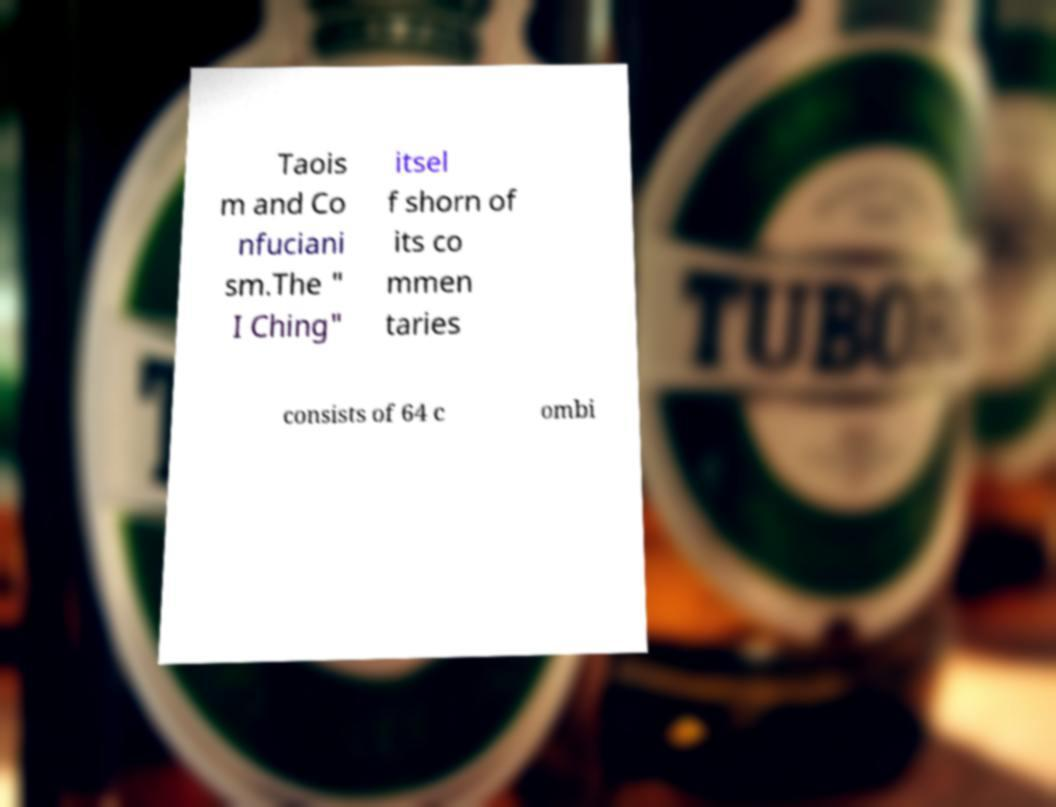Can you accurately transcribe the text from the provided image for me? Taois m and Co nfuciani sm.The " I Ching" itsel f shorn of its co mmen taries consists of 64 c ombi 